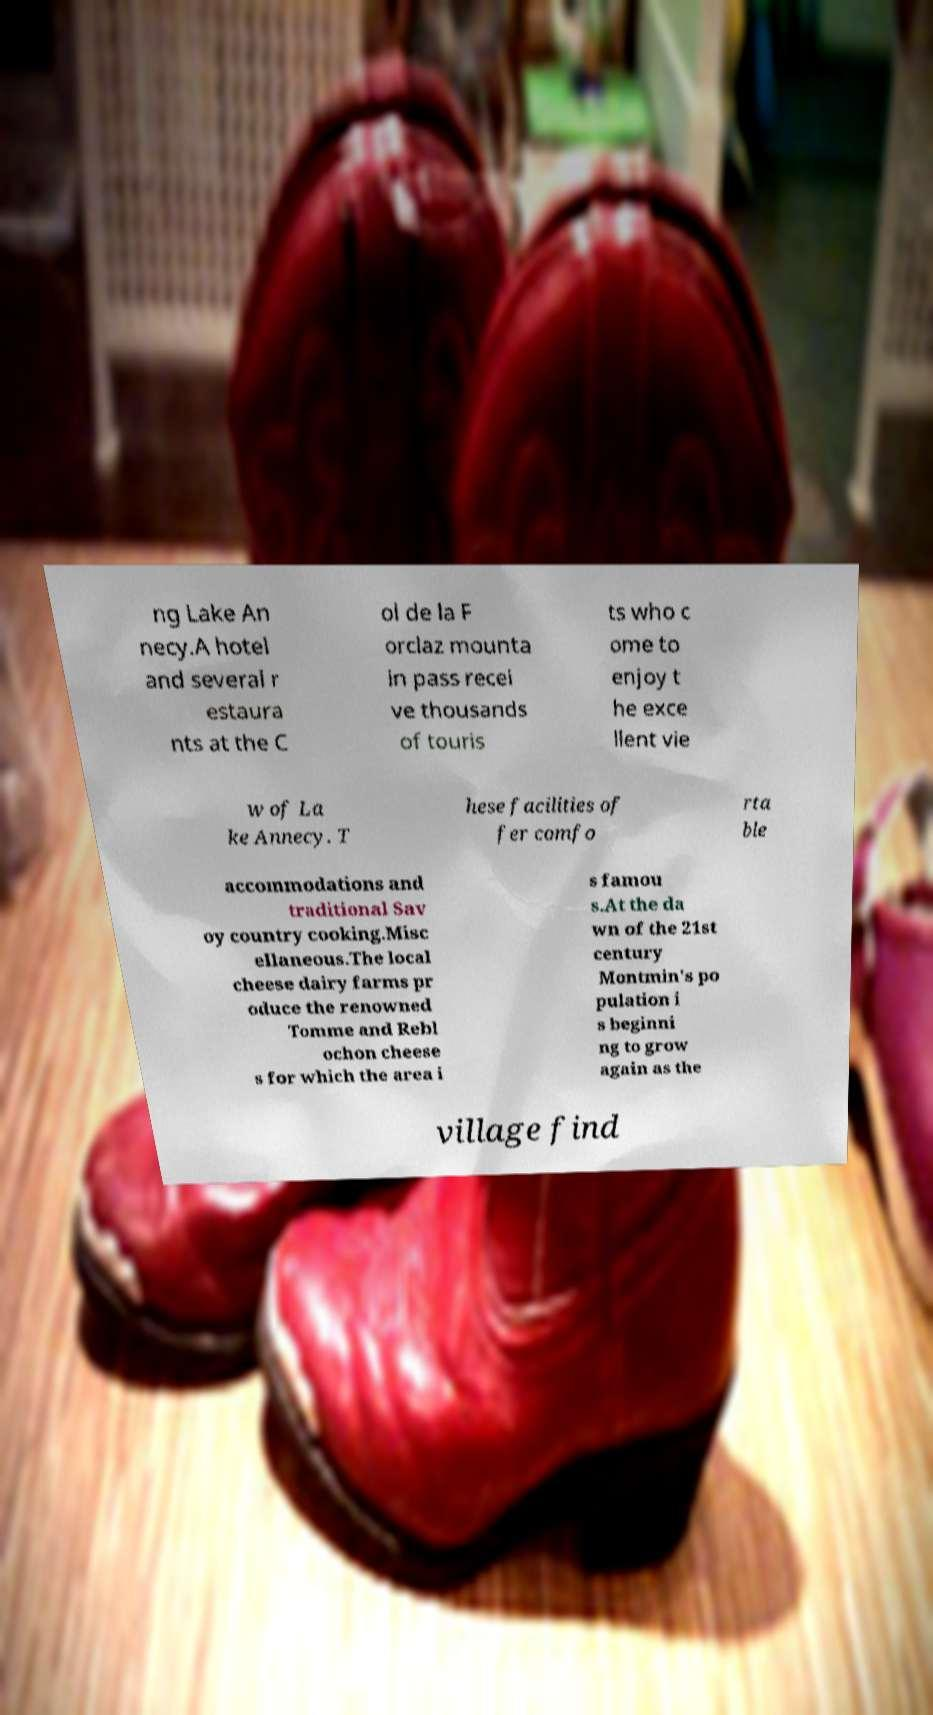Could you extract and type out the text from this image? ng Lake An necy.A hotel and several r estaura nts at the C ol de la F orclaz mounta in pass recei ve thousands of touris ts who c ome to enjoy t he exce llent vie w of La ke Annecy. T hese facilities of fer comfo rta ble accommodations and traditional Sav oy country cooking.Misc ellaneous.The local cheese dairy farms pr oduce the renowned Tomme and Rebl ochon cheese s for which the area i s famou s.At the da wn of the 21st century Montmin's po pulation i s beginni ng to grow again as the village find 